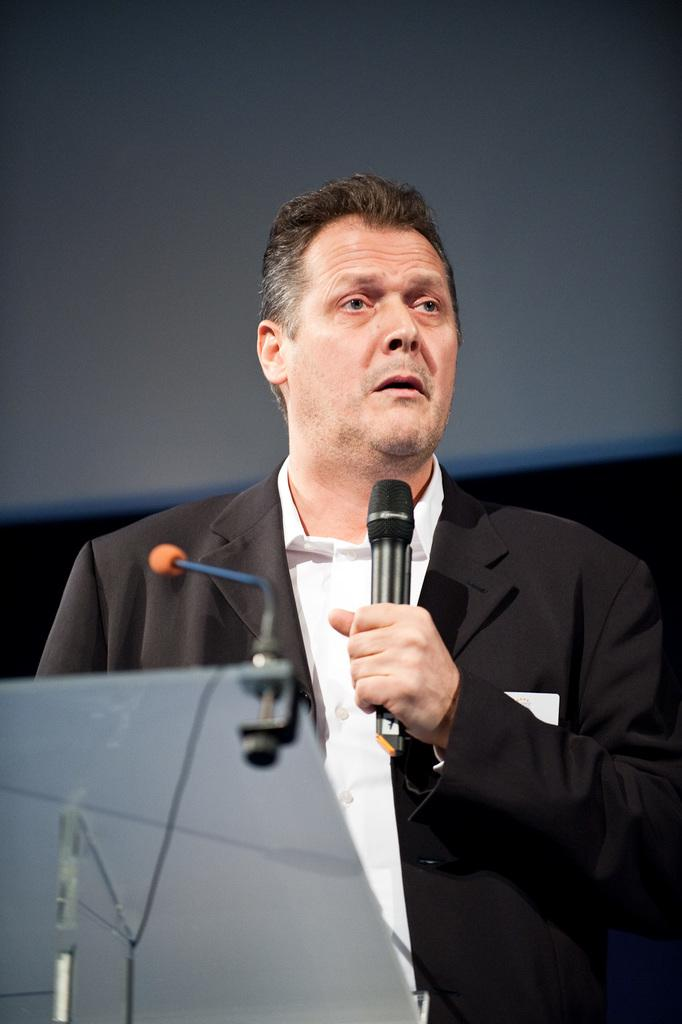Who is present in the image? There is a person in the image. What is the person holding in his hand? The person is holding a microphone in his hand. What other object related to the microphone can be seen in the image? There is a microphone on the table in the image. What piece of furniture is present in the image? There is a table in the image. Can you see any cactus plants in the image? No, there are no cactus plants present in the image. 